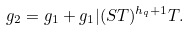<formula> <loc_0><loc_0><loc_500><loc_500>g _ { 2 } = g _ { 1 } + g _ { 1 } | ( S T ) ^ { h _ { q } + 1 } T .</formula> 